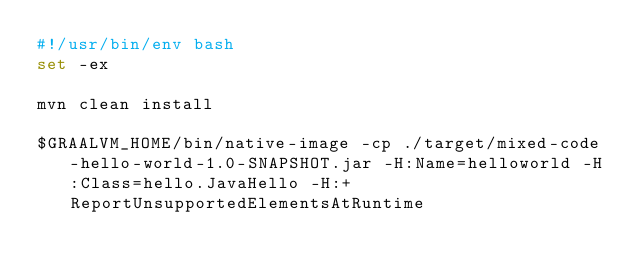Convert code to text. <code><loc_0><loc_0><loc_500><loc_500><_Bash_>#!/usr/bin/env bash
set -ex

mvn clean install

$GRAALVM_HOME/bin/native-image -cp ./target/mixed-code-hello-world-1.0-SNAPSHOT.jar -H:Name=helloworld -H:Class=hello.JavaHello -H:+ReportUnsupportedElementsAtRuntime
</code> 